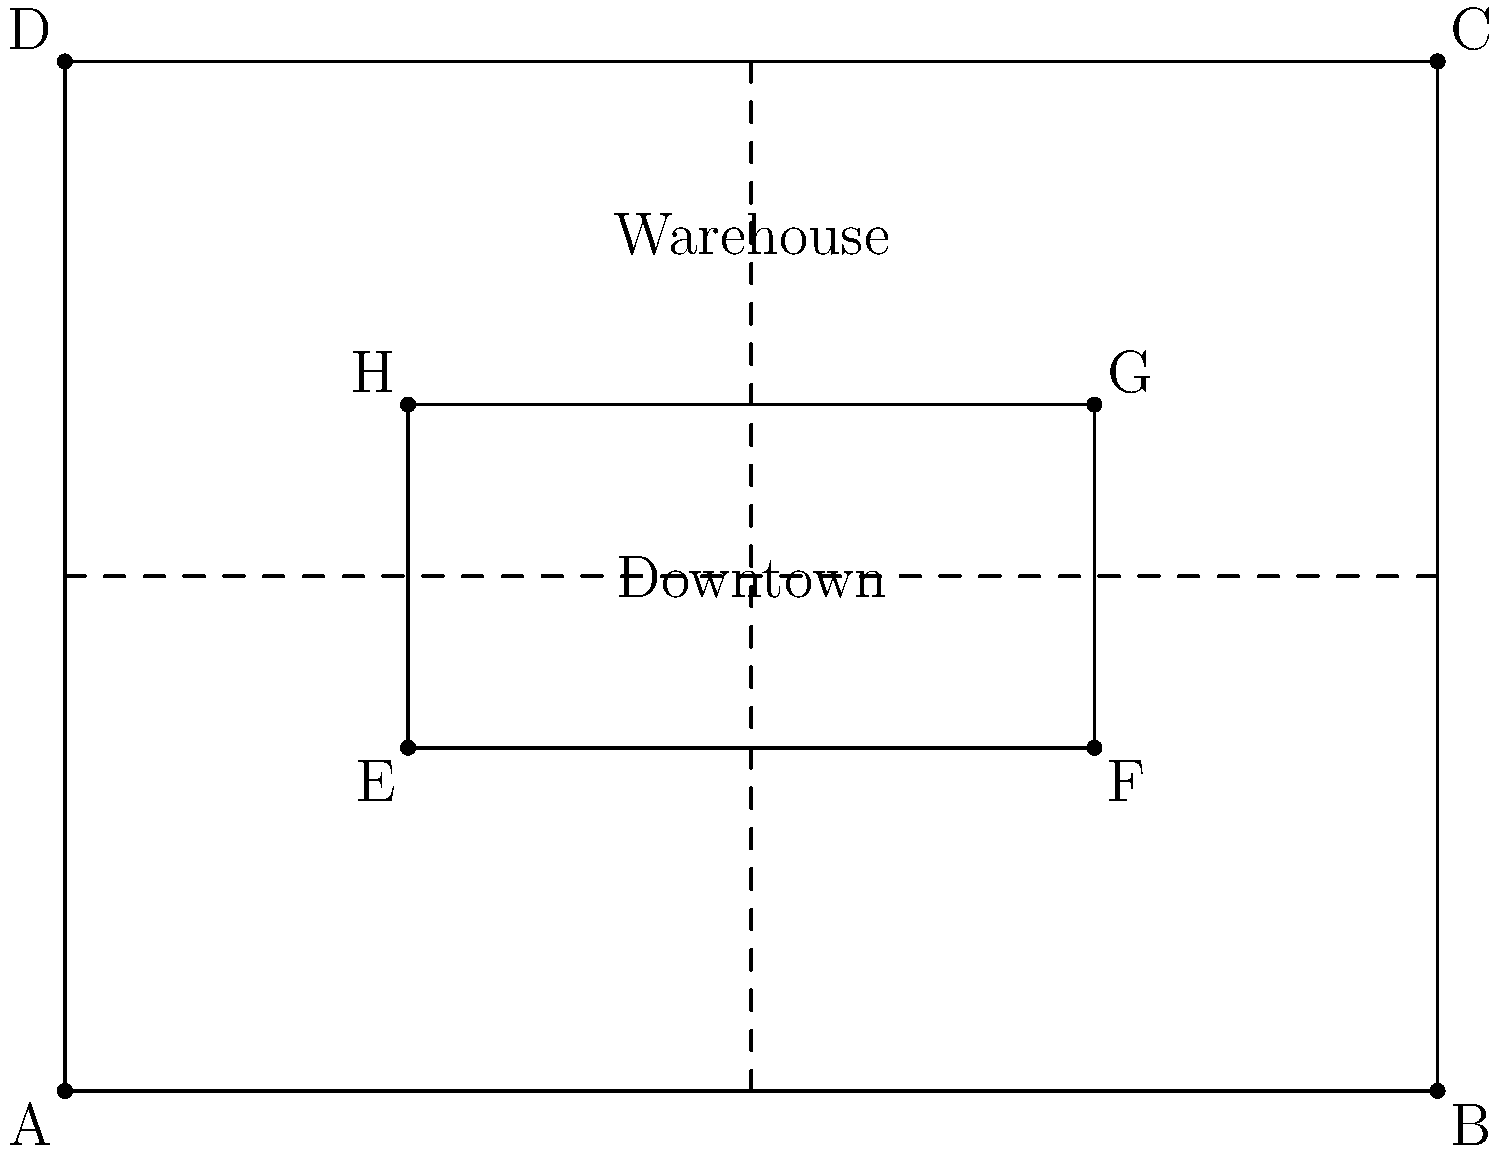Given the city map above, where the outer rectangle ABCD represents the city limits and the inner rectangle EFGH represents the downtown area, determine if triangles AEH and BGF are congruent. The warehouse is located at the center of the upper half of the map, and all delivery points are within the downtown area. How does this congruence affect route optimization for your truck fleet? To determine if triangles AEH and BGF are congruent and understand its impact on route optimization, let's follow these steps:

1. Analyze the properties of rectangles ABCD and EFGH:
   - ABCD and EFGH are rectangles, so they have four right angles each.
   - The inner rectangle EFGH is centered within ABCD.

2. Examine triangles AEH and BGF:
   - AE = BF (both are 2 units long)
   - EH = FG (both are 2 units long)
   - Angle AEH = Angle BGF = 90° (right angles of the rectangles)

3. Apply the Right Angle-Hypotenuse-Side (RHS) congruence theorem:
   - Both triangles have a right angle.
   - AH = BG (hypotenuse, both are diagonals of congruent rectangles)
   - AE = BF (side, as determined in step 2)
   - Therefore, triangles AEH and BGF are congruent.

4. Impact on route optimization:
   - The congruence of these triangles implies symmetry in the city layout.
   - This symmetry means that routes from the warehouse to points in the left half of downtown (triangle AEH) will have equivalent distances to corresponding points in the right half (triangle BGF).
   - For example, a route from the warehouse to point E will have the same distance as a route from the warehouse to point F.

5. Optimization strategies:
   - Utilize the symmetry to create balanced routes for your truck fleet.
   - When planning multiple deliveries, you can alternate between left and right sides of downtown to maintain consistent travel times and distances.
   - This symmetry allows for easier route planning and potentially more efficient fuel consumption across the fleet.
Answer: Yes, triangles AEH and BGF are congruent. This symmetry enables balanced route planning and consistent travel times across downtown Louisville. 